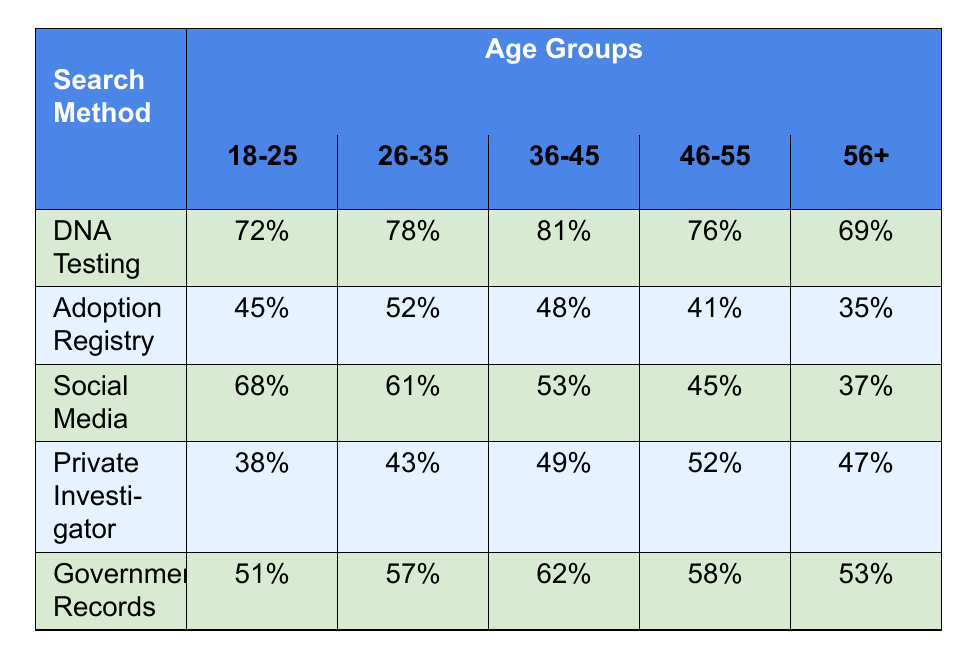What is the success rate of DNA Testing for the age group 36-45? Referring to the table, the value for DNA Testing in the age group 36-45 shows a success rate of 81%.
Answer: 81% Which search method has the highest success rate for the age group 26-35? Looking at the table, the success rates for age group 26-35 are: DNA Testing (78%), Adoption Registry (52%), Social Media (61%), Private Investigator (43%), and Government Records (57%). The highest is DNA Testing at 78%.
Answer: DNA Testing What is the average success rate of Government Records across all age groups? To calculate the average, sum the success rates for Government Records: (51 + 57 + 62 + 58 + 53) = 281. There are 5 age groups, so the average is 281/5 = 56.2%.
Answer: 56.2% Does the success rate of Social Media increase as age increases from 18-25 to 56+? Checking the Social Media success rates: 68% (18-25), 61% (26-35), 53% (36-45), 45% (46-55), and 37% (56+). The rates show a decrease as age increases.
Answer: No Which search method experienced the greatest decline in success rate from age group 18-25 to 56+? Analyzing the data: For DNA Testing, the rate dropped from 72% to 69% (3% decline). For Adoption Registry, it fell from 45% to 35% (10% decline). For Social Media, it dropped from 68% to 37% (31% decline). For Private Investigator, it decreased from 38% to 47% (9% increase). For Government Records, it fell from 51% to 53% (2% increase). Thus, Social Media had the greatest decline of 31%.
Answer: Social Media What is the overall trend in the success rates for the Adoption Registry across all age groups? Reviewing the success rates: 45% (18-25), 52% (26-35), 48% (36-45), 41% (46-55), and 35% (56+). The trend shows that the success rate increases from 18-25 to 26-35, then decreases thereafter.
Answer: Fluctuating with an overall decrease Which age group has the lowest success rate for Private Investigators? Looking at the table, the success rates for Private Investigators are 38% (18-25), 43% (26-35), 49% (36-45), 52% (46-55), and 47% (56+). The lowest rate is 38% for the age group 18-25.
Answer: 18-25 Is the success rate of DNA Testing higher for age group 46-55 or Government Records for age group 36-45? The success rate for DNA Testing in the 46-55 age group is 76%, while for Government Records in the 36-45 age group it is 62%. Therefore, DNA Testing is higher.
Answer: Yes What are the success rates of Social Media for the age groups 46-55 and 56+? The success rate for Social Media is 45% for 46-55 and 37% for 56+.
Answer: 45% and 37% 